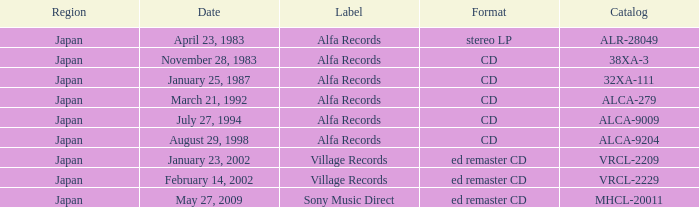Which date is in CD format? November 28, 1983, January 25, 1987, March 21, 1992, July 27, 1994, August 29, 1998. 